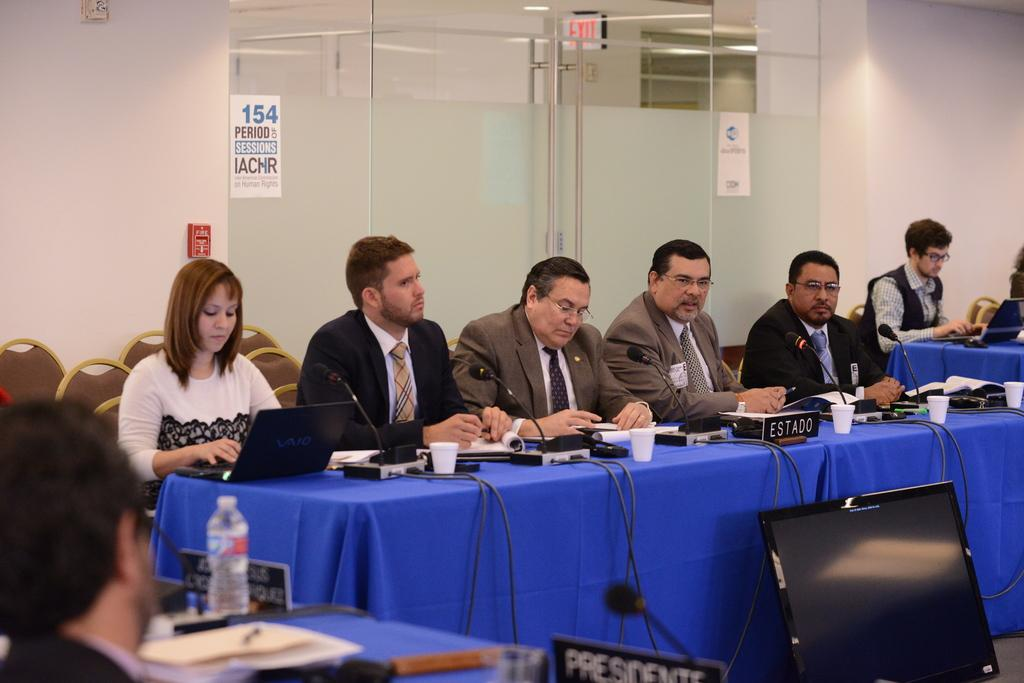<image>
Offer a succinct explanation of the picture presented. A group of people at a table with Estado on the sign on it. 